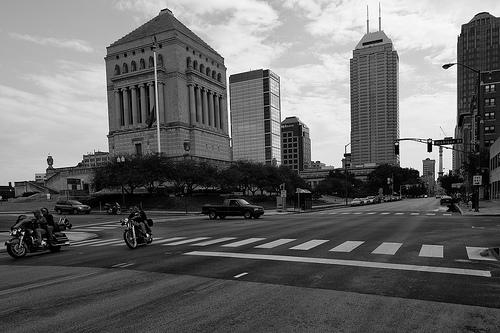Provide a brief description of the urban environment portrayed in the image. The image showcases a lively city intersection complete with vehicles, street signs, traffic lights, and surrounding buildings with trees. Describe the basic elements of an urban scene as seen in the image. The image displays a bustling urban landscape with busy streets, vehicles, traffic lights, street signs, crosswalks, and surrounding buildings. Provide a concise description of the primary modes of transportation present in the image. There are cars, motorcycles, and a pickup truck navigating the roads and parked along the streets in the image. Assuming the observer's vantage point, tell what is happening in the image. From where I stand, I see a busy intersection with vehicles navigating the roads, traffic lights regulating movement, crosswalks providing safety, and tall buildings in the backdrop. Relay what is transpiring in the image using a metaphor. Amidst the forest of buildings and trees, the dance of vehicles weaves through the city's streets, guided by the illuminating eyes of traffic lights. Mention the main components of the urban landscape in the image. The image features a crosswalk, traffic lights, street signs, parked vehicles, motorcycles on the road, buildings with antennas, and trees lining the street. In an imaginative manner, describe the key features found in the image. Under the watchful gaze of tall buildings with radio antennae, motorcycles swiftly cut through an urban jungle while parked vehicles sit silently by the trees. Write a brief summary of what the overall scene depicts within the image. The image shows a busy city intersection with various vehicles in motion, traffic signs and lights, crosswalks, and tall buildings surrounded by trees. Identify the key elements of infrastructure present in the image. Crosswalks, traffic lights, street signs, buildings, sidewalks, and trees are the key infrastructure elements present in the image. List the street-level items visible in the image. Crosswalks, vehicles, motorcycles, traffic lights, street signs, sidewalk corners, and trees. 